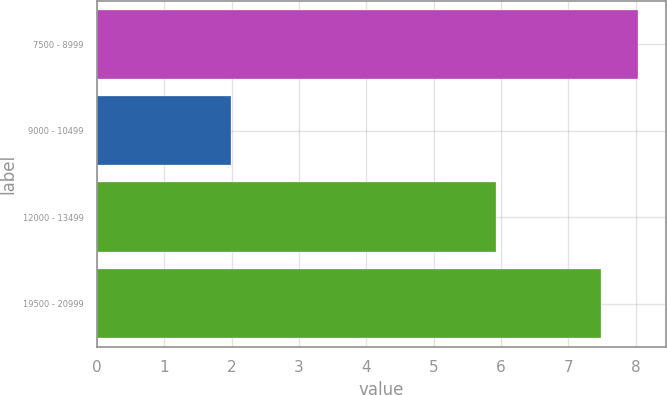Convert chart. <chart><loc_0><loc_0><loc_500><loc_500><bar_chart><fcel>7500 - 8999<fcel>9000 - 10499<fcel>12000 - 13499<fcel>19500 - 20999<nl><fcel>8.04<fcel>1.99<fcel>5.92<fcel>7.48<nl></chart> 